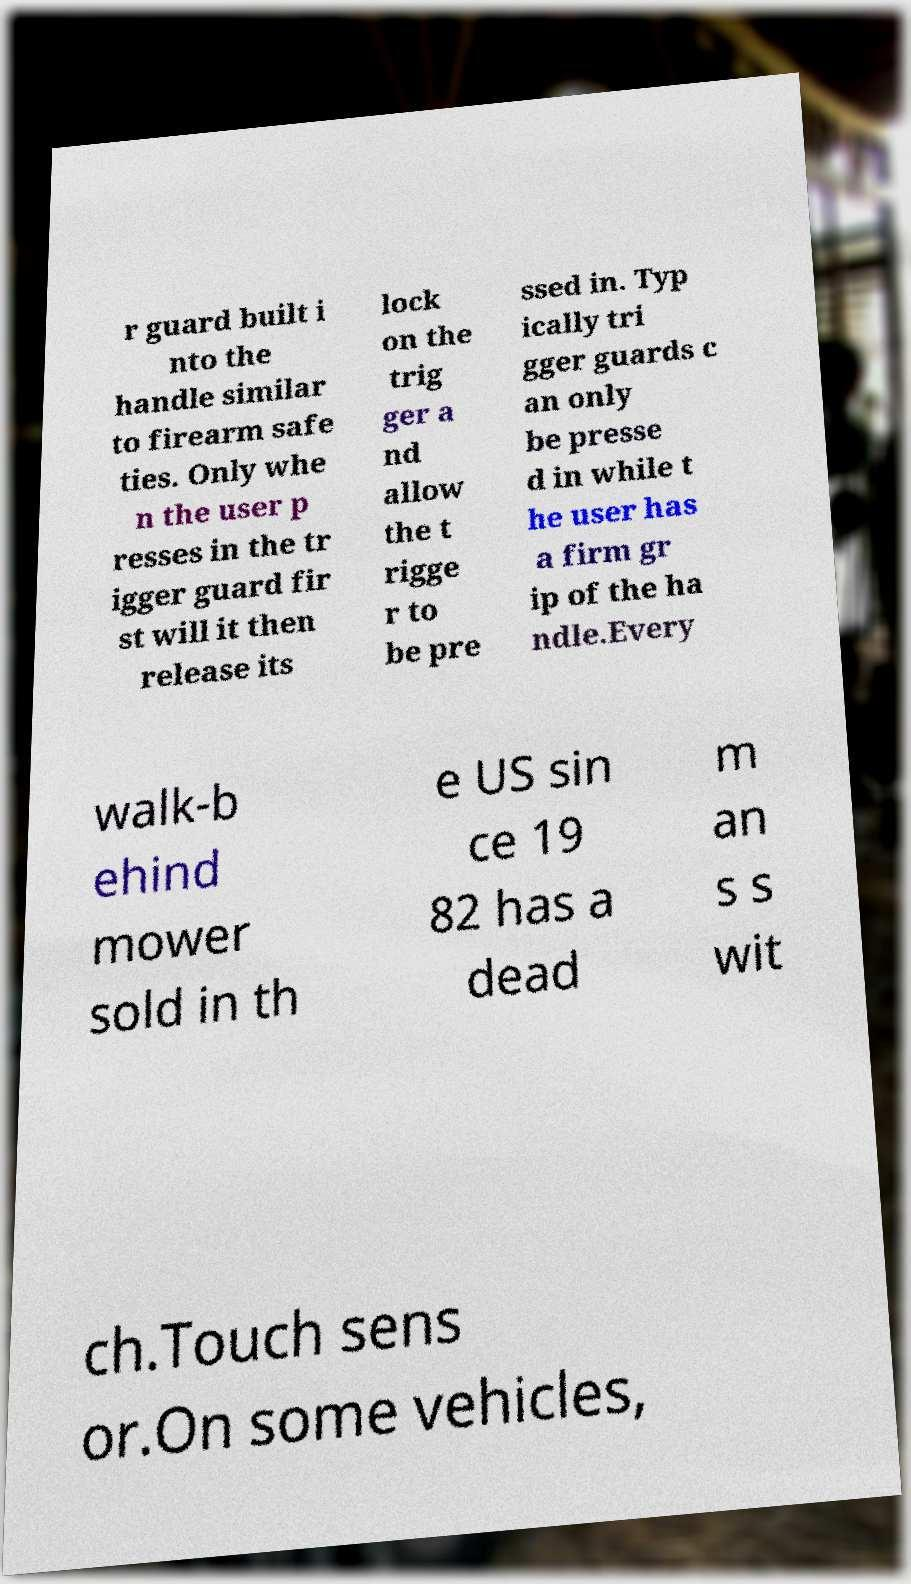Please read and relay the text visible in this image. What does it say? r guard built i nto the handle similar to firearm safe ties. Only whe n the user p resses in the tr igger guard fir st will it then release its lock on the trig ger a nd allow the t rigge r to be pre ssed in. Typ ically tri gger guards c an only be presse d in while t he user has a firm gr ip of the ha ndle.Every walk-b ehind mower sold in th e US sin ce 19 82 has a dead m an s s wit ch.Touch sens or.On some vehicles, 